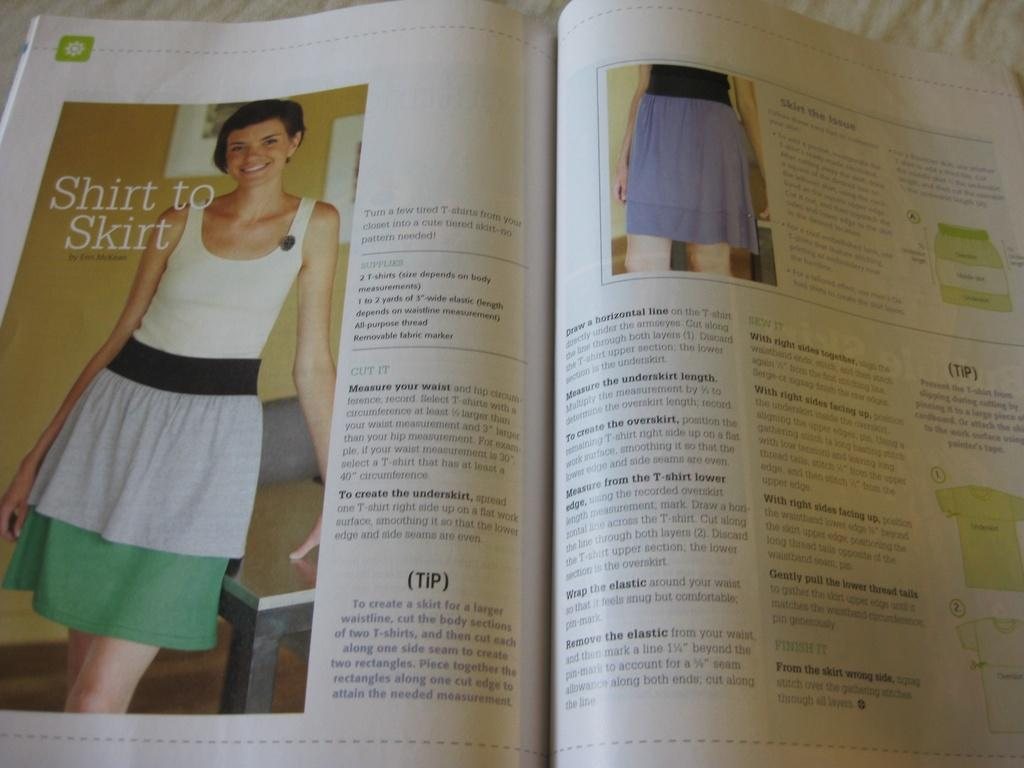<image>
Give a short and clear explanation of the subsequent image. Fashion book of a woman that has the text Shirt to Skirt. 